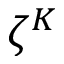<formula> <loc_0><loc_0><loc_500><loc_500>\zeta ^ { K }</formula> 